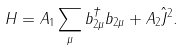<formula> <loc_0><loc_0><loc_500><loc_500>H = A _ { 1 } \sum _ { \mu } b ^ { \dagger } _ { 2 \mu } b _ { 2 \mu } + A _ { 2 } \hat { J } ^ { 2 } .</formula> 